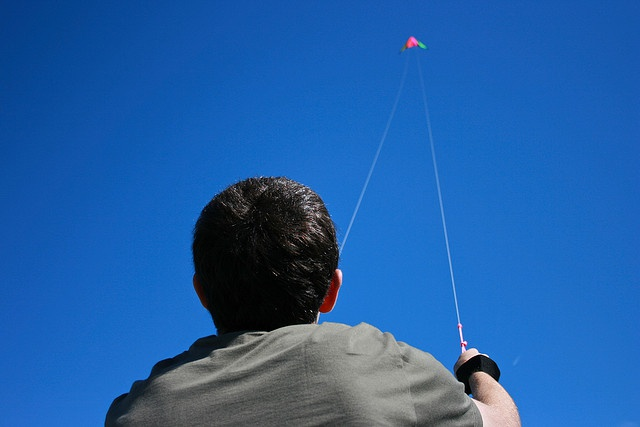Describe the objects in this image and their specific colors. I can see people in darkblue, black, gray, and darkgray tones and kite in darkblue, blue, violet, salmon, and gray tones in this image. 